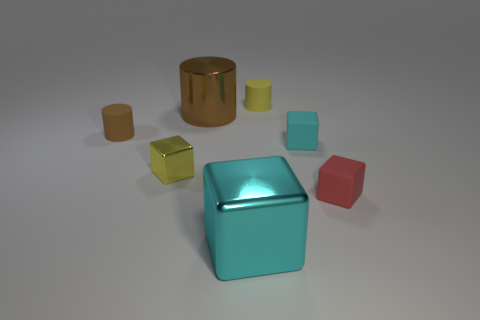Can you tell me about the textures of the objects? Absolutely, the objects exhibit a variety of textures: the cylinder and cube seem to have a smooth, perhaps metallic surface with soft reflections, while the round object appears to have a slightly matte finish suggesting a different material, possibly a kind of plastic or brushed metal. And how about the lighting in the scene? The lighting appears soft and diffused, casting gentle shadows on the ground, creating a sense of tranquility and clarity that highlights the colors and shapes of the objects without creating harsh reflections. 